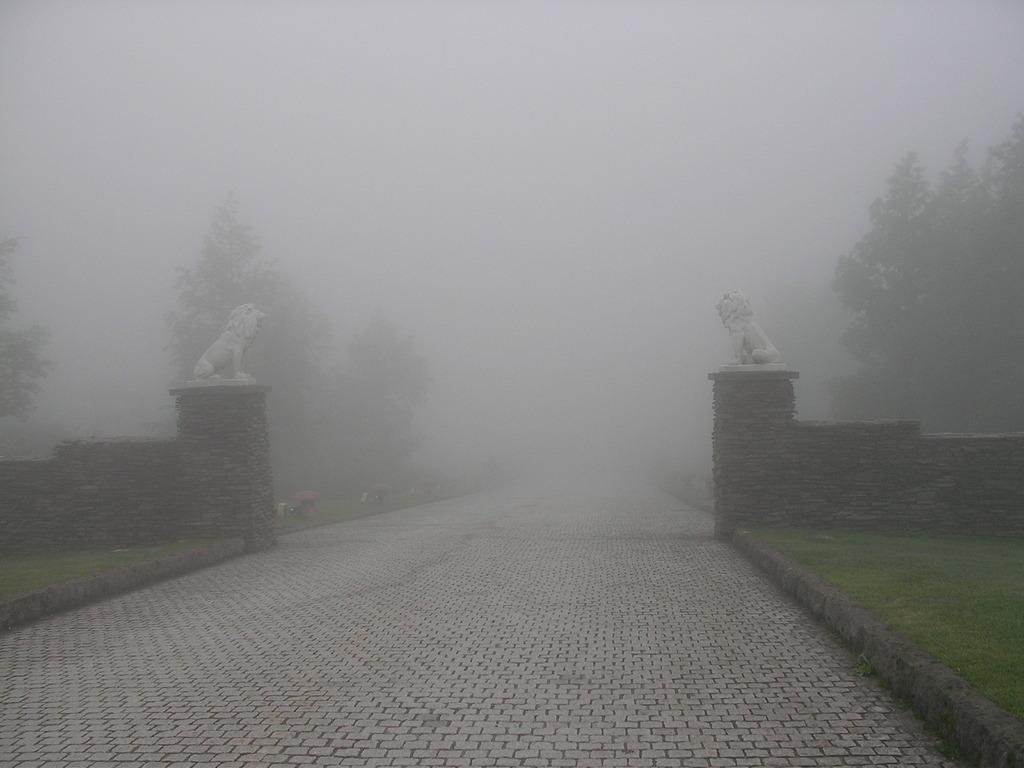Please provide a concise description of this image. In this image I can see the road. To the side of the road I can see the statues on the wall. In the background I can see many trees and the fog. 